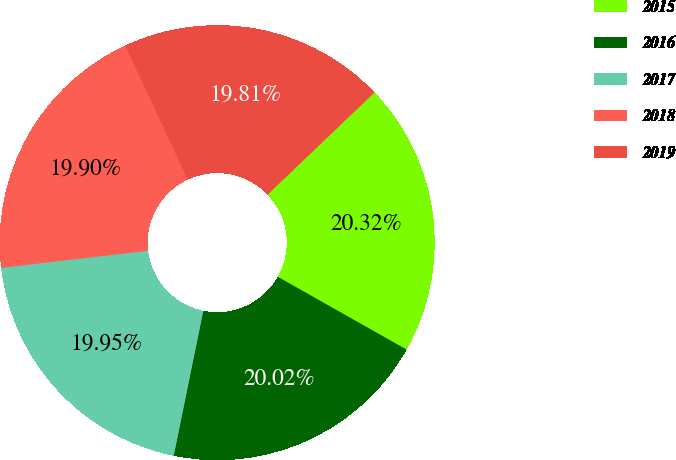Convert chart to OTSL. <chart><loc_0><loc_0><loc_500><loc_500><pie_chart><fcel>2015<fcel>2016<fcel>2017<fcel>2018<fcel>2019<nl><fcel>20.32%<fcel>20.02%<fcel>19.95%<fcel>19.9%<fcel>19.81%<nl></chart> 